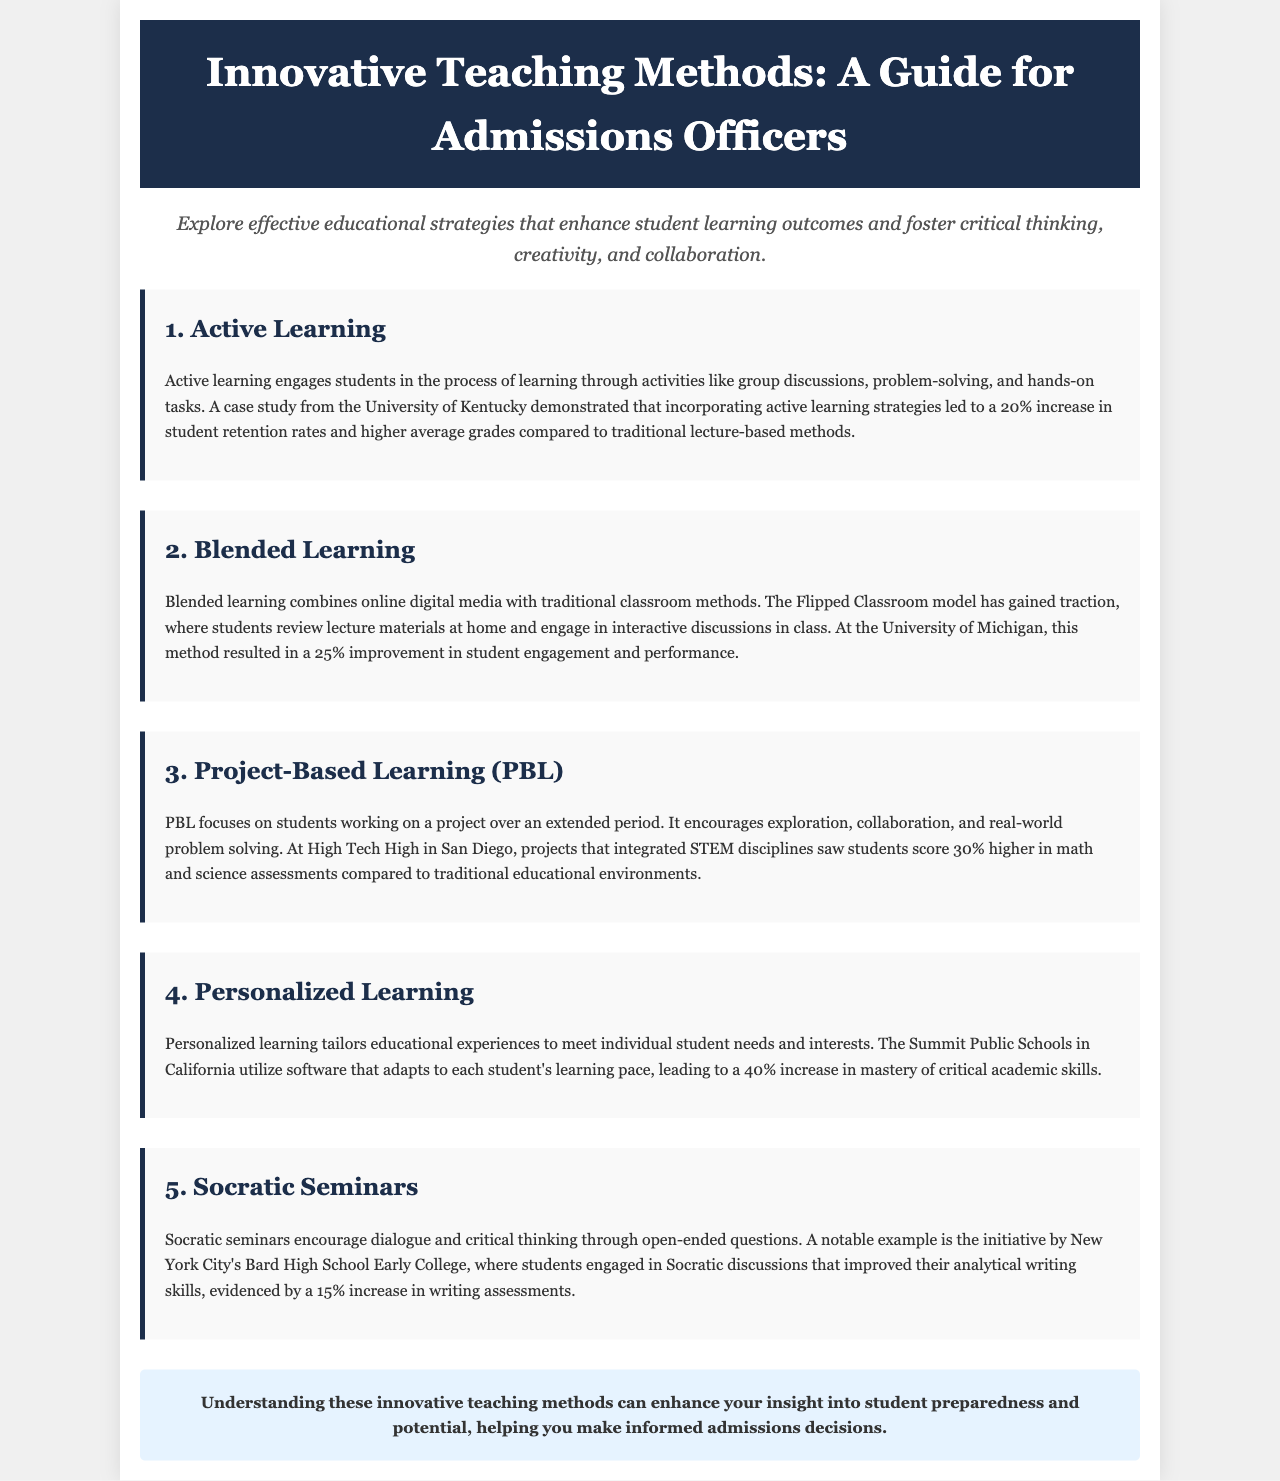What is the title of the document? The title of the document is found in the header section.
Answer: Innovative Teaching Methods: A Guide for Admissions Officers What is the primary focus of the brochure? The primary focus is mentioned in the introductory paragraph.
Answer: Effective educational strategies What percentage increase in retention rates was reported by the University of Kentucky? The specific percentage increase is provided within the active learning section.
Answer: 20% What innovative learning method resulted in a 25% improvement in student engagement? The specific method and its impact is detailed in the blended learning section.
Answer: Blended learning Which school utilized technology to tailor educational experiences to individual needs? The name of the school is mentioned in the personalized learning section.
Answer: Summit Public Schools What is the main advantage of Project-Based Learning as mentioned in the document? The advantage is summarized in the section discussing PBL.
Answer: Real-world problem solving How much higher did students score in assessments at High Tech High compared to traditional environments? The percentage increase is specifically stated in the PBL section.
Answer: 30% What method improved students' analytical writing skills by 15%? The method and its impact are outlined in the Socratic seminars section.
Answer: Socratic seminars What is the final emphasis of the brochure regarding admissions decisions? The conclusion provides insight on the overall intent of understanding these methods.
Answer: Student preparedness and potential 